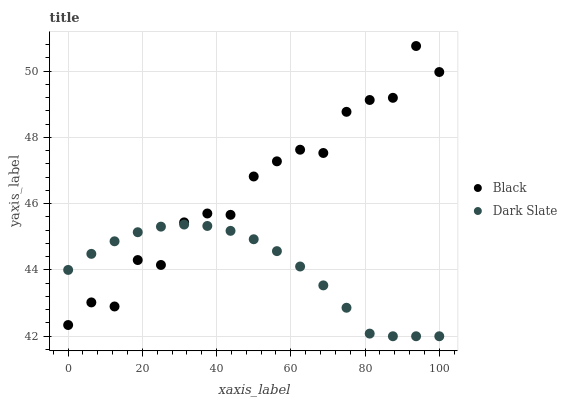Does Dark Slate have the minimum area under the curve?
Answer yes or no. Yes. Does Black have the maximum area under the curve?
Answer yes or no. Yes. Does Black have the minimum area under the curve?
Answer yes or no. No. Is Dark Slate the smoothest?
Answer yes or no. Yes. Is Black the roughest?
Answer yes or no. Yes. Is Black the smoothest?
Answer yes or no. No. Does Dark Slate have the lowest value?
Answer yes or no. Yes. Does Black have the lowest value?
Answer yes or no. No. Does Black have the highest value?
Answer yes or no. Yes. Does Black intersect Dark Slate?
Answer yes or no. Yes. Is Black less than Dark Slate?
Answer yes or no. No. Is Black greater than Dark Slate?
Answer yes or no. No. 